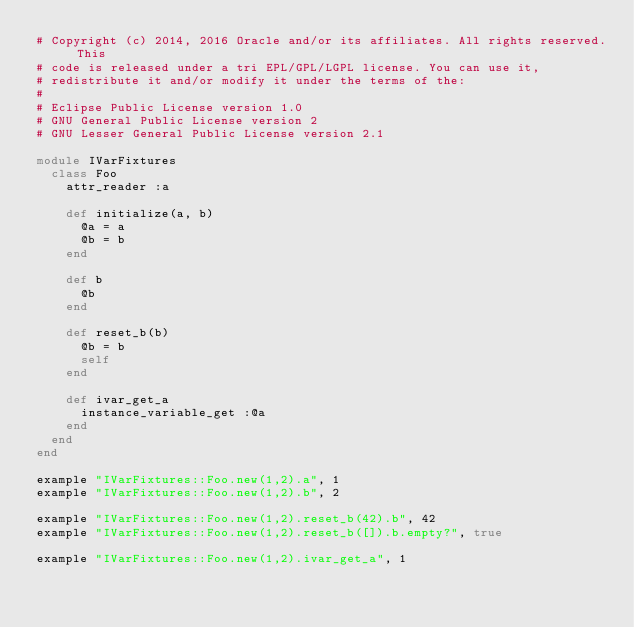Convert code to text. <code><loc_0><loc_0><loc_500><loc_500><_Ruby_># Copyright (c) 2014, 2016 Oracle and/or its affiliates. All rights reserved. This
# code is released under a tri EPL/GPL/LGPL license. You can use it,
# redistribute it and/or modify it under the terms of the:
#
# Eclipse Public License version 1.0
# GNU General Public License version 2
# GNU Lesser General Public License version 2.1

module IVarFixtures
  class Foo
    attr_reader :a

    def initialize(a, b)
      @a = a
      @b = b
    end

    def b
      @b
    end

    def reset_b(b)
      @b = b
      self
    end

    def ivar_get_a
      instance_variable_get :@a
    end
  end
end

example "IVarFixtures::Foo.new(1,2).a", 1
example "IVarFixtures::Foo.new(1,2).b", 2

example "IVarFixtures::Foo.new(1,2).reset_b(42).b", 42
example "IVarFixtures::Foo.new(1,2).reset_b([]).b.empty?", true

example "IVarFixtures::Foo.new(1,2).ivar_get_a", 1
</code> 